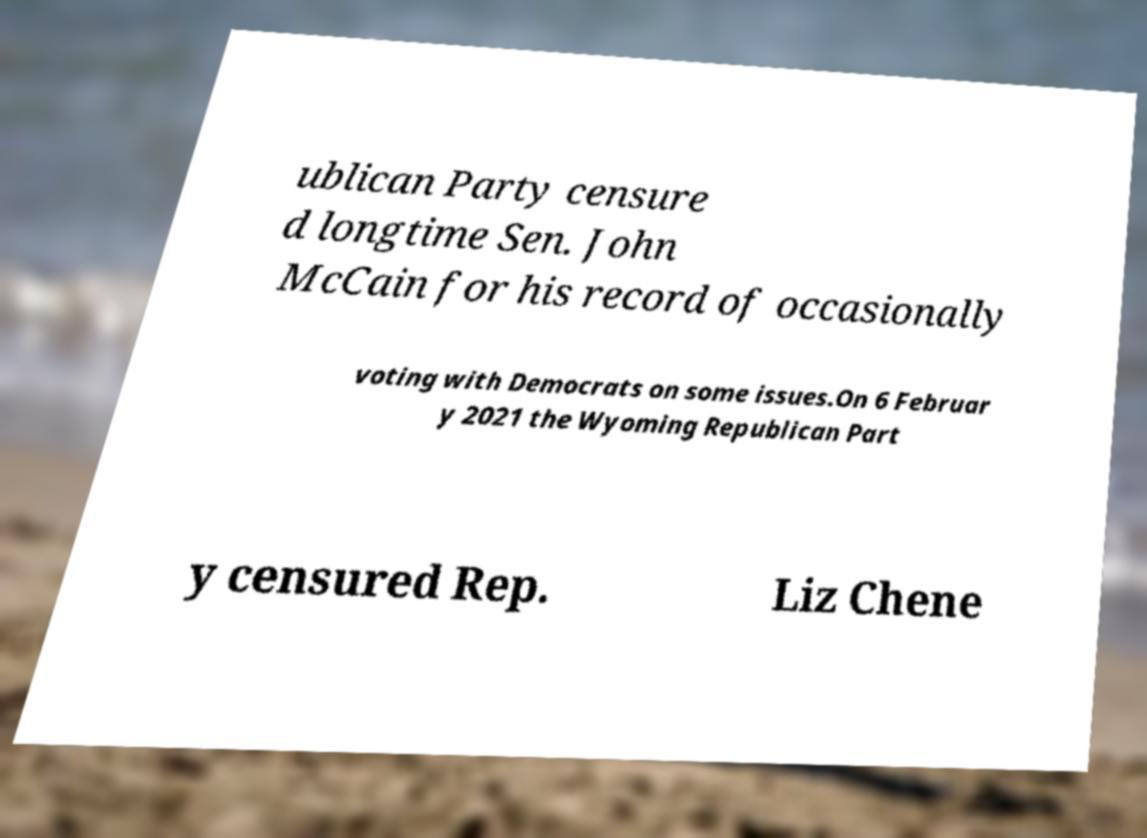Could you extract and type out the text from this image? ublican Party censure d longtime Sen. John McCain for his record of occasionally voting with Democrats on some issues.On 6 Februar y 2021 the Wyoming Republican Part y censured Rep. Liz Chene 